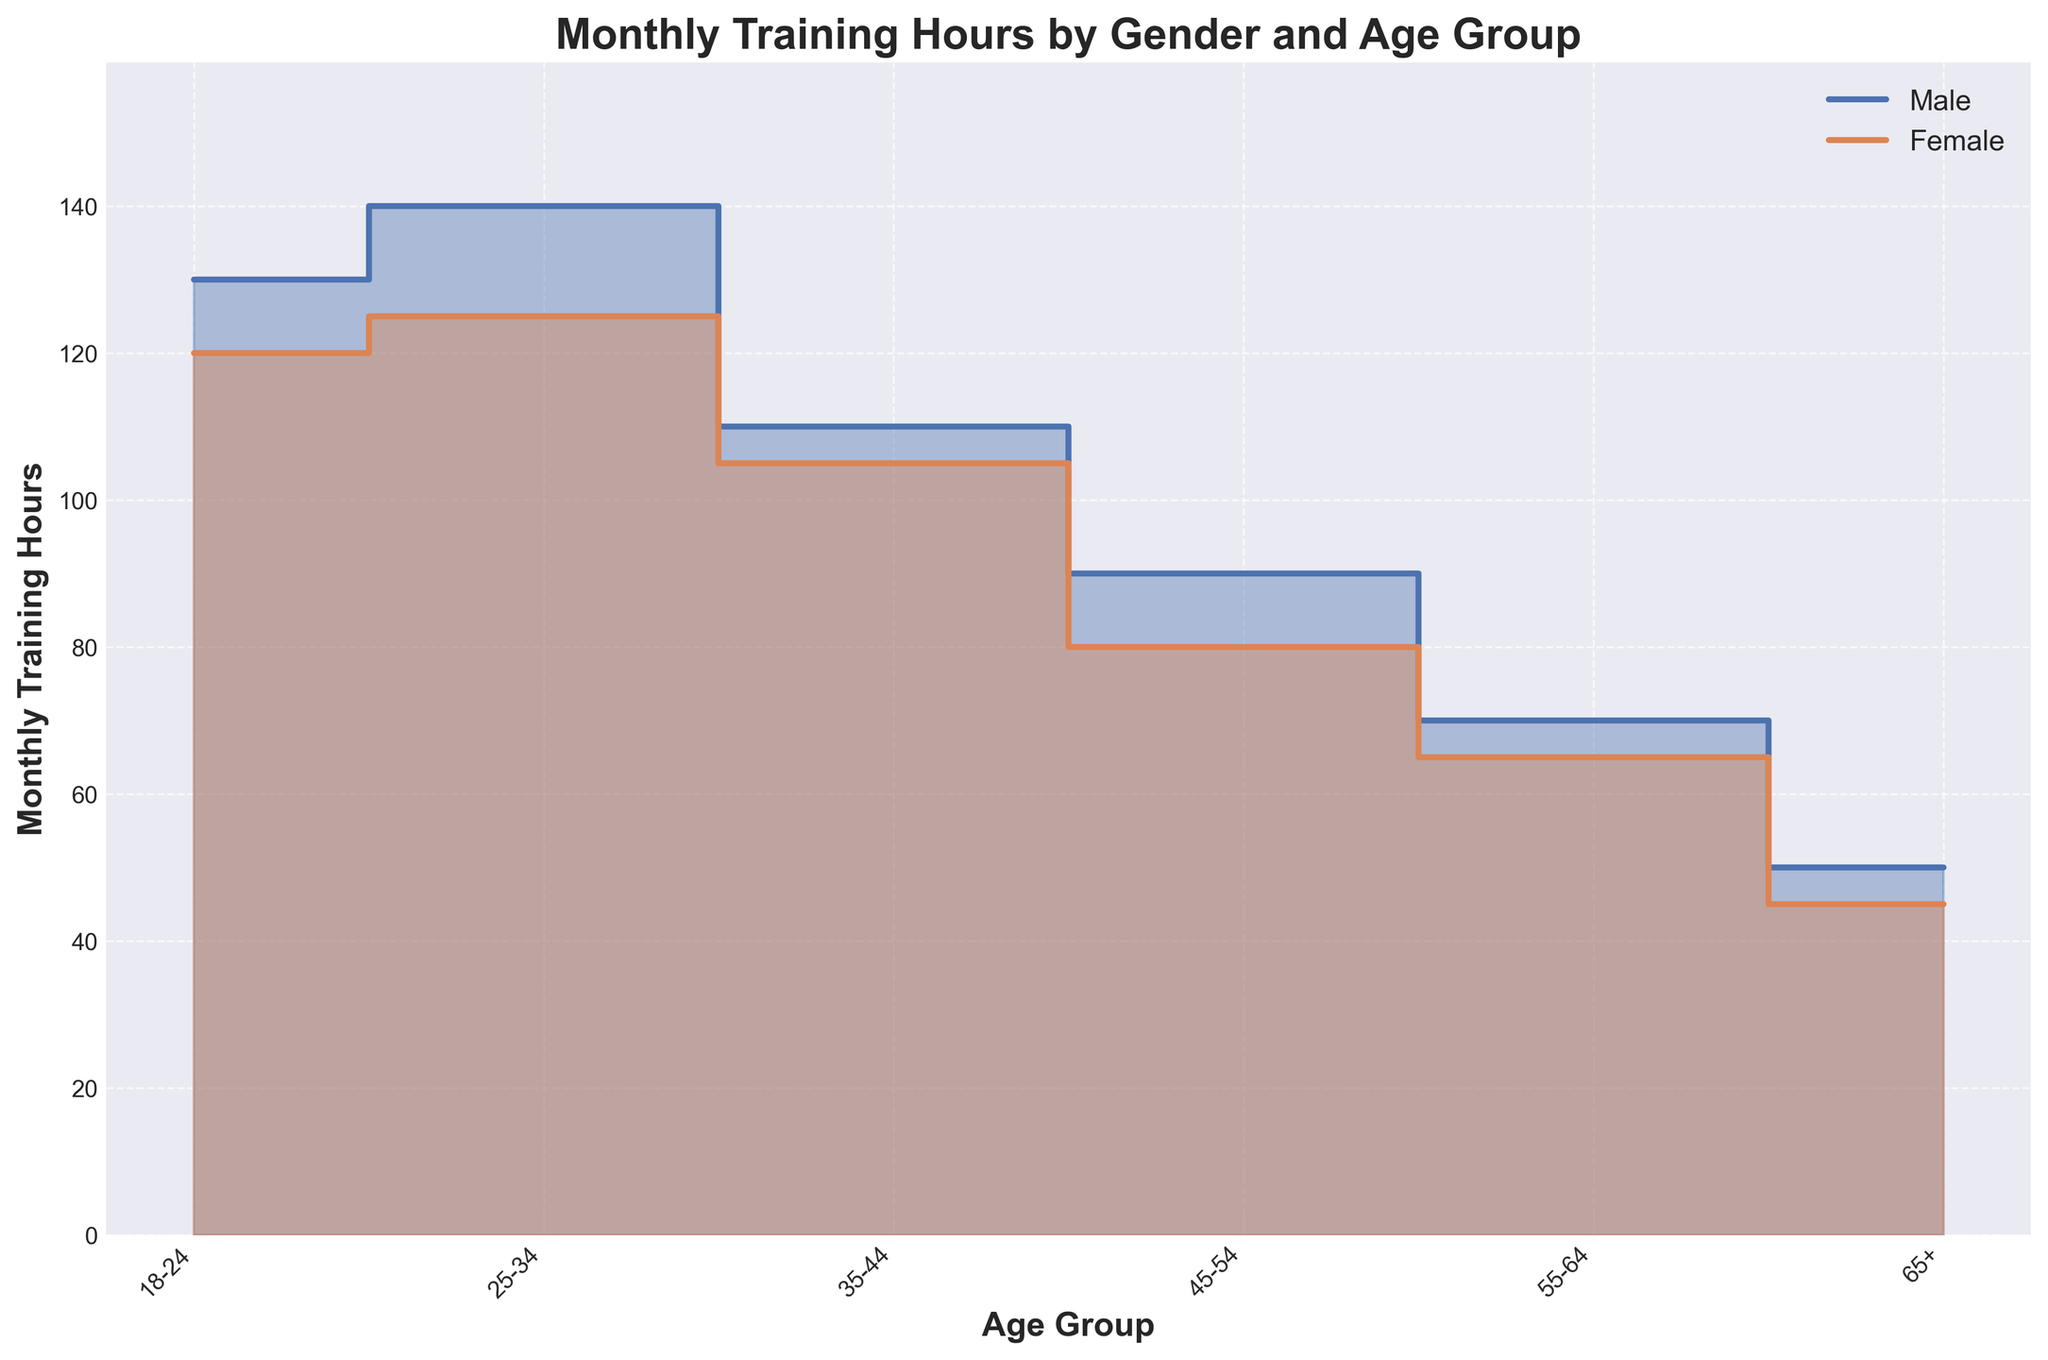What is the title of the chart? The title is typically found at the top center of the chart. In this figure, it is displayed in a bold, larger font for visibility.
Answer: Monthly Training Hours by Gender and Age Group How many distinct age groups are represented in the chart? The x-axis labels show distinct age groups. Counting them provides the answer.
Answer: 6 Which gender has the highest monthly training hours for the age group 25-34? The step area chart shows two lines, one for each gender. For the age group 25-34, compare the heights of the steps.
Answer: Male What are the monthly training hours for females in the age group 45-54? Refer to the value on the y-axis where the female line for the 45-54 age group is positioned.
Answer: 85 Are there any age groups where males and females train for the same number of hours? To answer this, look at the step lines to see if they coincide at any point across all age groups.
Answer: No Which gender has the least monthly training hours in the age group 55-64? Compare the heights of the male and female lines for the 55-64 age group on the step area chart.
Answer: Female What is the average monthly training hours for males across all age groups? Find the sum of monthly training hours for males across all age groups (130 + 140 + 110 + 90 + 70 + 50 + 135 + 145 + 120 + 95 + 75 + 55 = 1215) and divide by the number of data points (12).
Answer: 101.25 By how much do the monthly training hours of males exceed those of females in the age group 18-24? Find the difference in monthly training hours for males and females (135 - 115).
Answer: 20 Which age group shows the maximum difference in training hours between males and females? Calculate the difference for each age group and identify the maximum difference (145 - 130 = 15 for 25-34, which is the highest).
Answer: 25-34 In which age group do females train for fewer hours than males but have a smaller difference compared to other age groups? Calculate the difference in training hours for each age group where males train more hours, then identify the age group with the smallest difference (105 - 110 = 5 for 35-44).
Answer: 35-44 